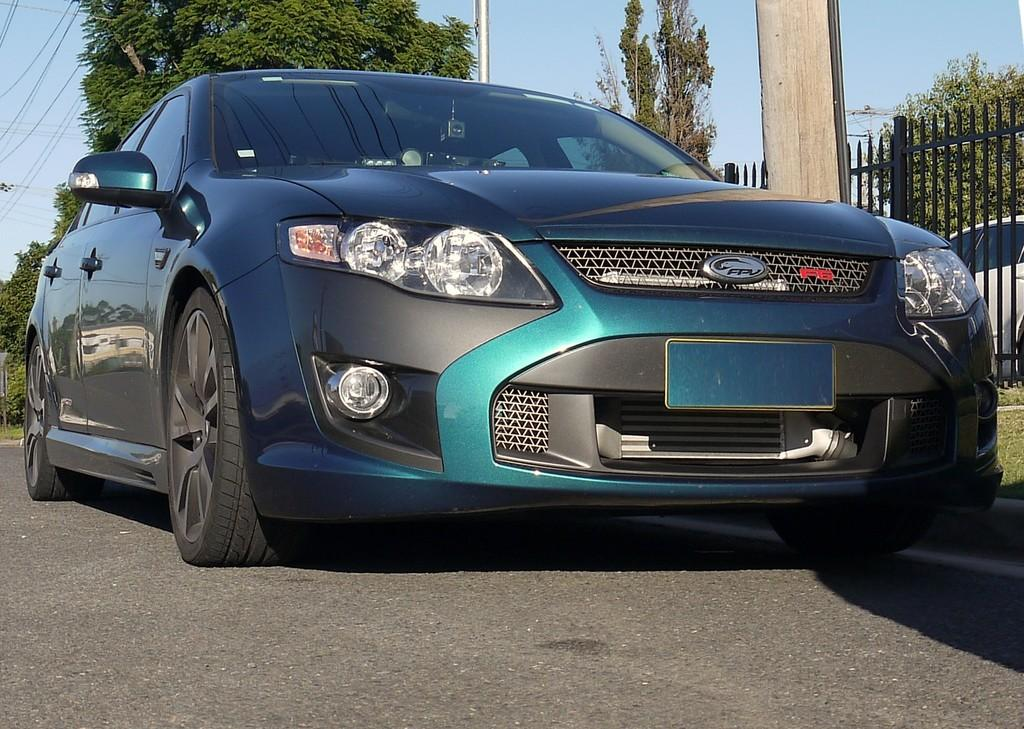What is the main subject of the image? The main subject of the image is a car on the road. What can be seen on the right side of the image? There is a rail on the right side of the image. What is visible in the background of the image? There are trees and the sky visible in the background of the image. How many chairs can be seen in the image? There are no chairs present in the image. What type of cherry is growing on the trees in the background? There are no cherries visible in the image, and the trees are not specified as cherry trees. 